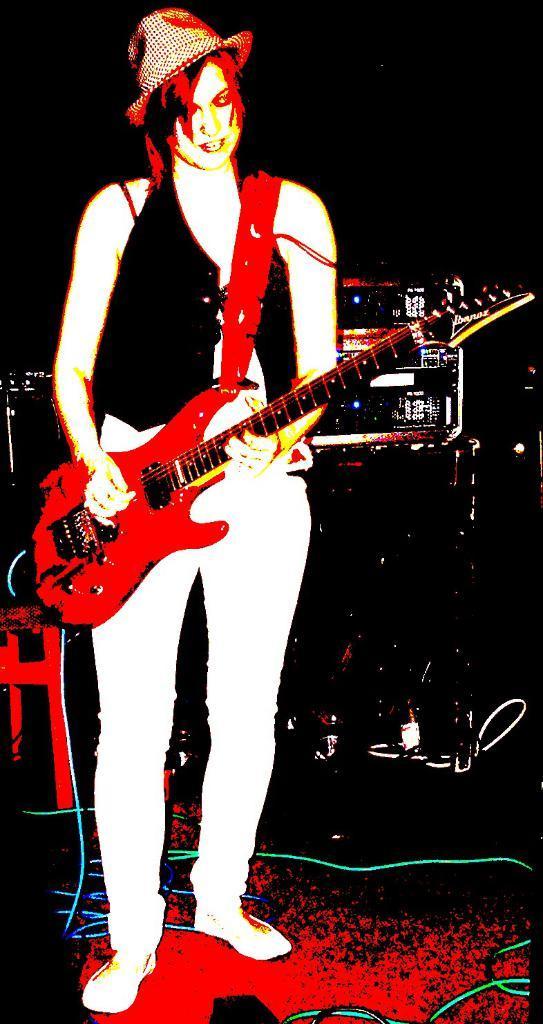Please provide a concise description of this image. This looks like an edited image. I can see the woman standing and playing the guitar. She wore T-shirt, hat, trouser and shoes. In the background, I can see the electronic devices. These are the wires on the floor. The background looks dark. 